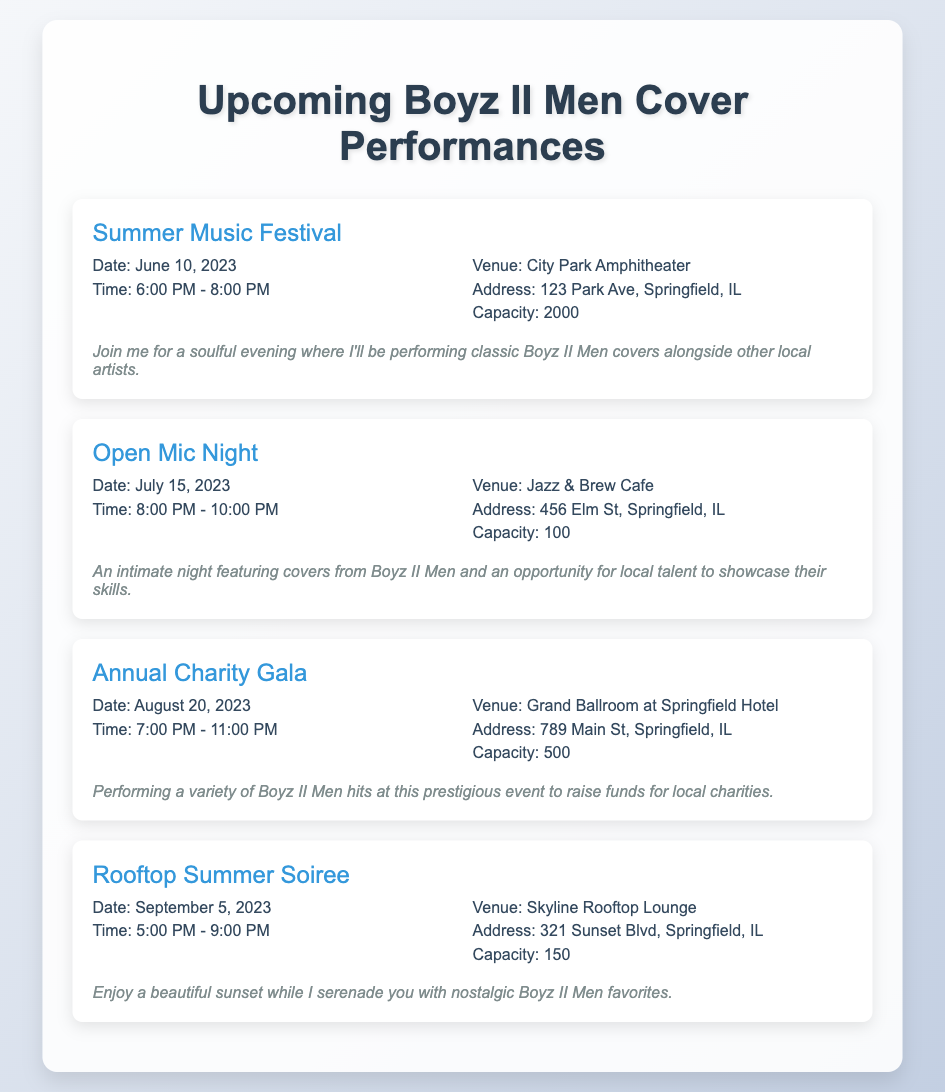what is the date of the Summer Music Festival? The date is specifically listed in the document for the Summer Music Festival event.
Answer: June 10, 2023 where is the Open Mic Night held? The venue address for the Open Mic Night is provided in the document.
Answer: 456 Elm St, Springfield, IL what time does the Annual Charity Gala start? The starting time is detailed under the event section for the Annual Charity Gala.
Answer: 7:00 PM how many events are listed in the agenda? The document outlines a series of events, which can be counted to find the total number of performances.
Answer: 4 what is the capacity of the Skyline Rooftop Lounge? The capacity for this venue is stated alongside its event details in the document.
Answer: 150 which event takes place in August? The event listed for August is specifically mentioned, leading to a clear identification based on the event names.
Answer: Annual Charity Gala what type of event is the Rooftop Summer Soiree? The document describes the Rooftop Summer Soiree, detailing its nature based on the context of performances.
Answer: Soiree who is performing at the events? The document refers to the performer of the covers, identifying their involvement with a specific reference.
Answer: Me (the singer) 